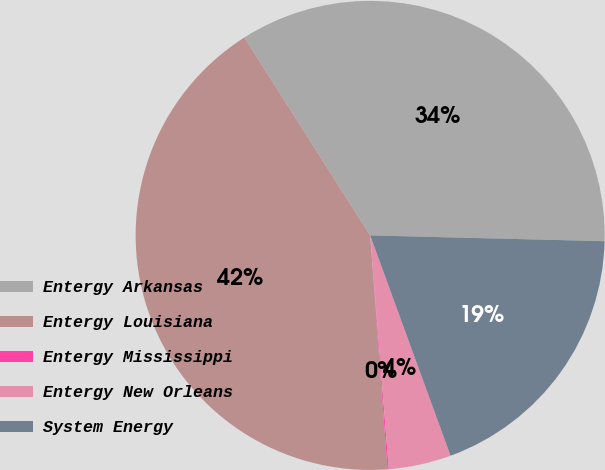Convert chart to OTSL. <chart><loc_0><loc_0><loc_500><loc_500><pie_chart><fcel>Entergy Arkansas<fcel>Entergy Louisiana<fcel>Entergy Mississippi<fcel>Entergy New Orleans<fcel>System Energy<nl><fcel>34.4%<fcel>42.17%<fcel>0.09%<fcel>4.3%<fcel>19.04%<nl></chart> 